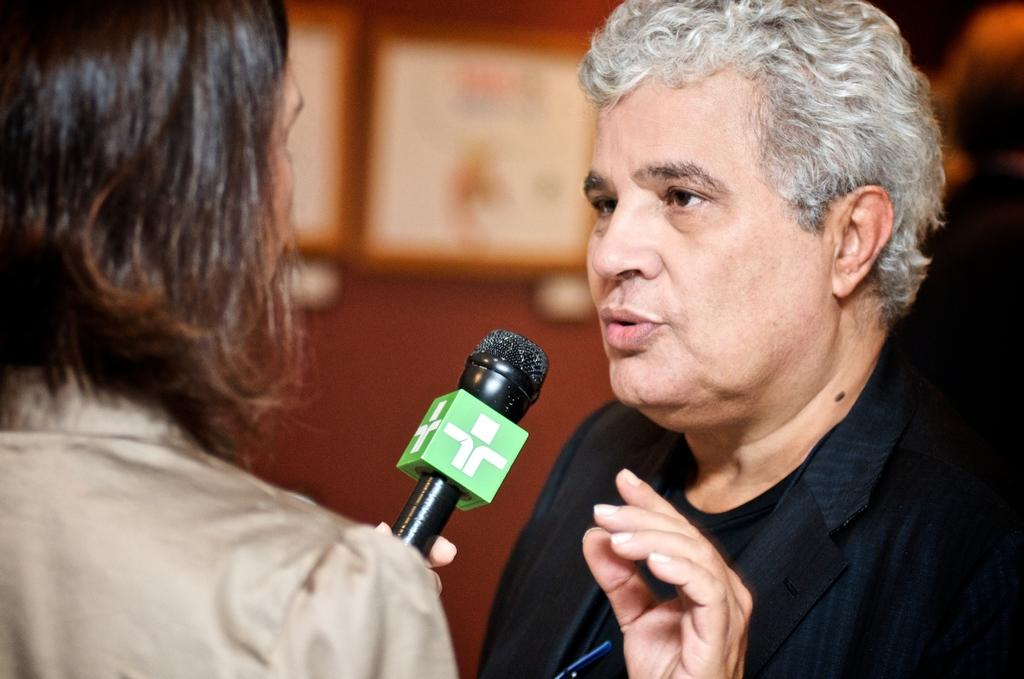How many people are in the image? There are two persons in the image. What is one of the persons holding? One of the persons is holding a mic. What can be seen in the background of the image? There is a wall in the background of the image. What type of apples can be seen growing on the plantation in the image? There is no plantation or apples present in the image. 